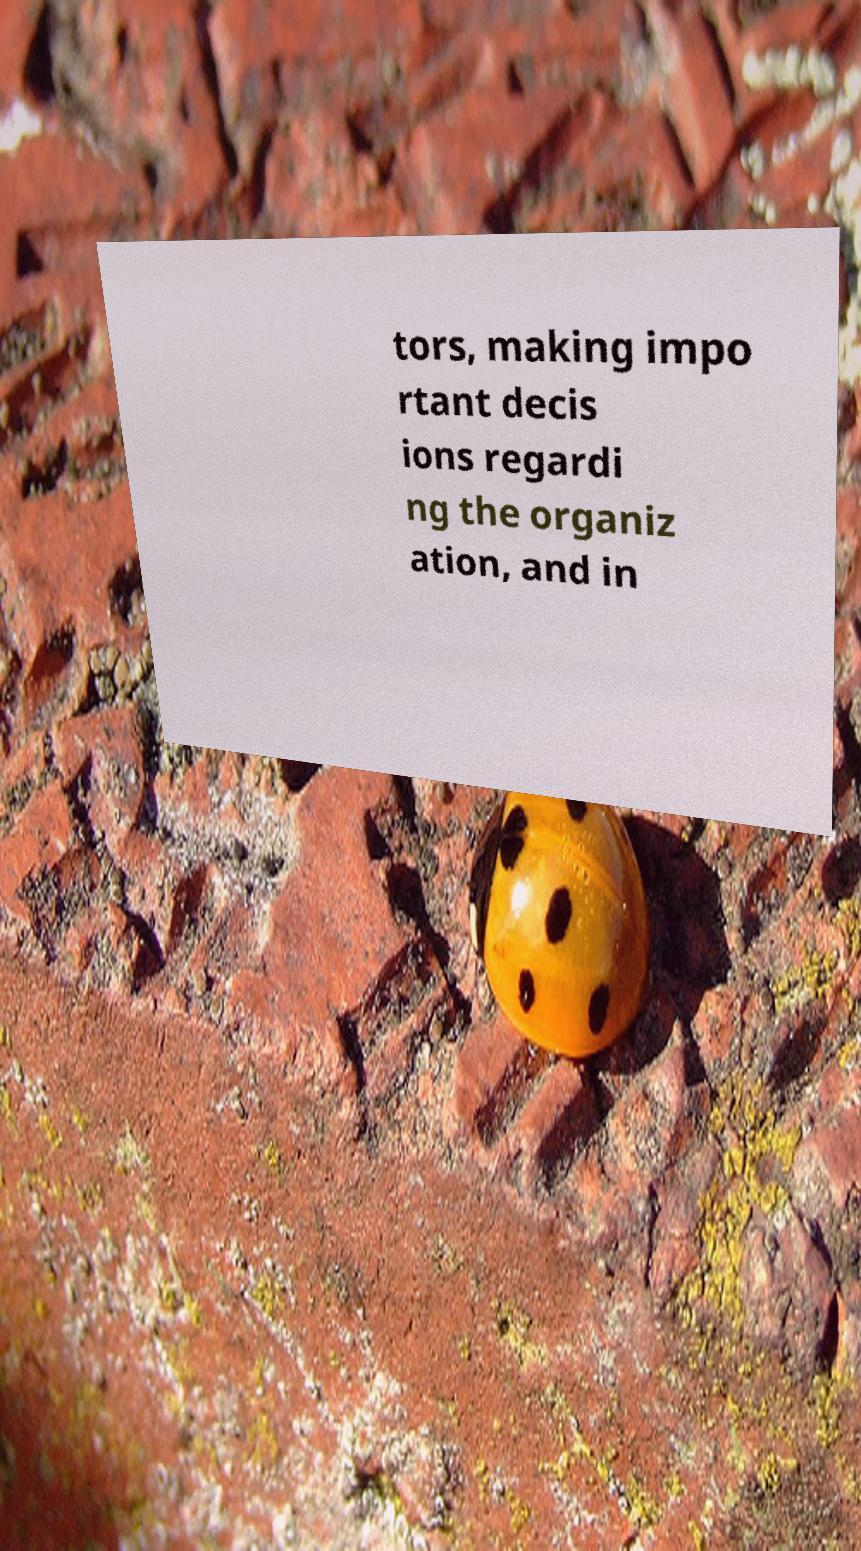What messages or text are displayed in this image? I need them in a readable, typed format. tors, making impo rtant decis ions regardi ng the organiz ation, and in 